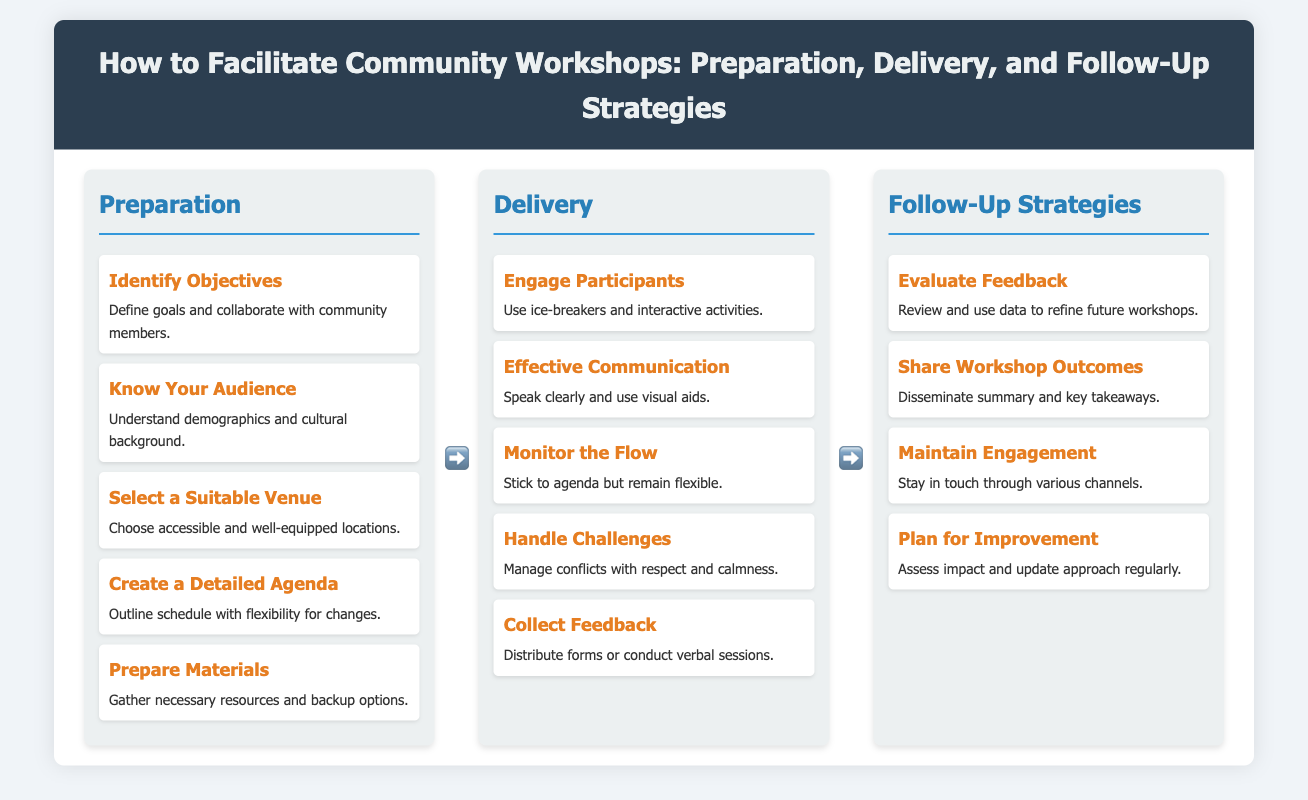what is the first step in the Preparation section? The first step outlined in the Preparation section is "Identify Objectives."
Answer: Identify Objectives how many steps are there in the Delivery section? The Delivery section contains five steps listed in the infographic.
Answer: 5 what is one method to engage participants according to the Delivery section? The infographic suggests using "ice-breakers" as a method to engage participants.
Answer: ice-breakers which section discusses evaluating feedback? The section that discusses evaluating feedback is the Follow-Up Strategies section.
Answer: Follow-Up Strategies what is a key action in the Follow-Up Strategies for maintaining engagement? The Follow-Up Strategies section mentions the importance of staying in touch through various channels.
Answer: Stay in touch what can be found in the step named "Prepare Materials"? The step named "Prepare Materials" discusses gathering necessary resources and backup options.
Answer: Gather necessary resources and backup options what is the purpose of creating a detailed agenda? The purpose of creating a detailed agenda is to outline the schedule with flexibility for changes.
Answer: Outline the schedule with flexibility for changes what is the general focus of the infographic? The general focus of the infographic is on facilitating community workshops.
Answer: Facilitating community workshops 